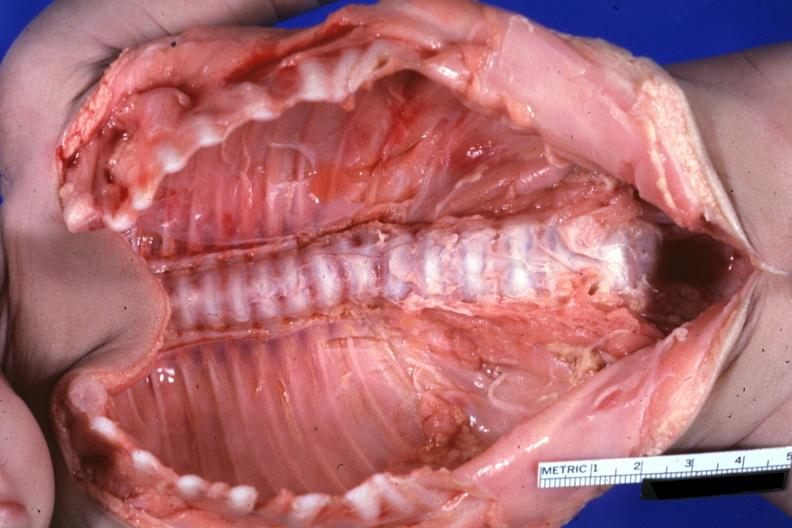do metastatic carcinoma lung see protocol?
Answer the question using a single word or phrase. No 